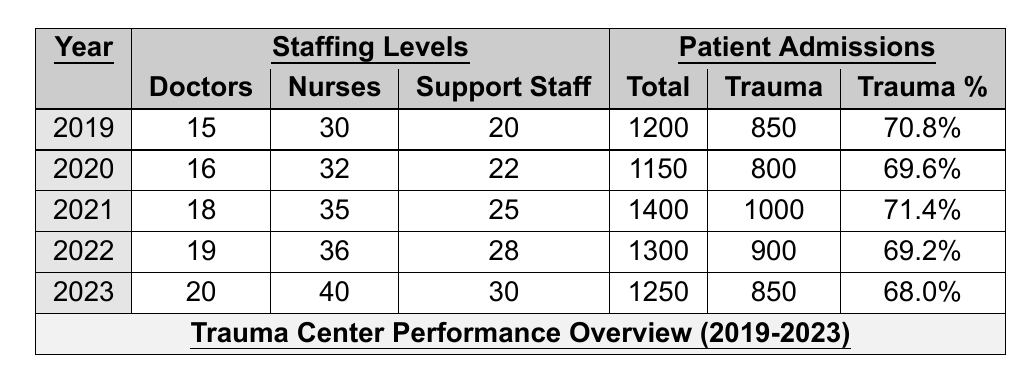What's the total number of doctors in the trauma center in 2021? The table shows that there are 18 doctors listed for the year 2021.
Answer: 18 How many total patient admissions were recorded in 2020? The table indicates that the total admissions for the year 2020 are 1150.
Answer: 1150 What is the percentage of trauma-related admissions in 2019? The table lists 850 trauma admissions out of 1200 total admissions for 2019. To find the percentage, we calculate (850 / 1200) * 100 = 70.8%.
Answer: 70.8% Which year saw the highest number of total admissions? By examining the total admissions for each year, 2021 has the highest total admissions of 1400.
Answer: 2021 Did the number of nurses increase every year from 2019 to 2023? The table shows that the number of nurses increased from 30 in 2019 to 40 in 2023 for each year in between.
Answer: Yes What was the average number of total admissions from 2019 to 2023? To find the average, we sum total admissions for each year: (1200 + 1150 + 1400 + 1300 + 1250) = 6150. Then divide by 5 years: 6150 / 5 = 1230.
Answer: 1230 In which year did the trauma admissions drop below 900? The table shows drop below 900 occurred in 2020 and 2023, where trauma admissions were 800 and 850, respectively.
Answer: 2020, 2023 What was the staffing level of support staff in 2022 compared to 2019? The table shows that support staff was 28 in 2022 and 20 in 2019, indicating an increase of 8 support staff.
Answer: Increased by 8 How did the trauma admission percentage change from 2021 to 2023? In 2021, the trauma admission percentage was 71.4%, and in 2023 it dropped to 68.0%. This is a decrease of 3.4 percentage points.
Answer: Decreased by 3.4 percentage points In which year did the trauma center have the highest percentage of trauma admissions? Comparing the trauma admission percentages, 2021 with 71.4% is the highest among all the years listed.
Answer: 2021 